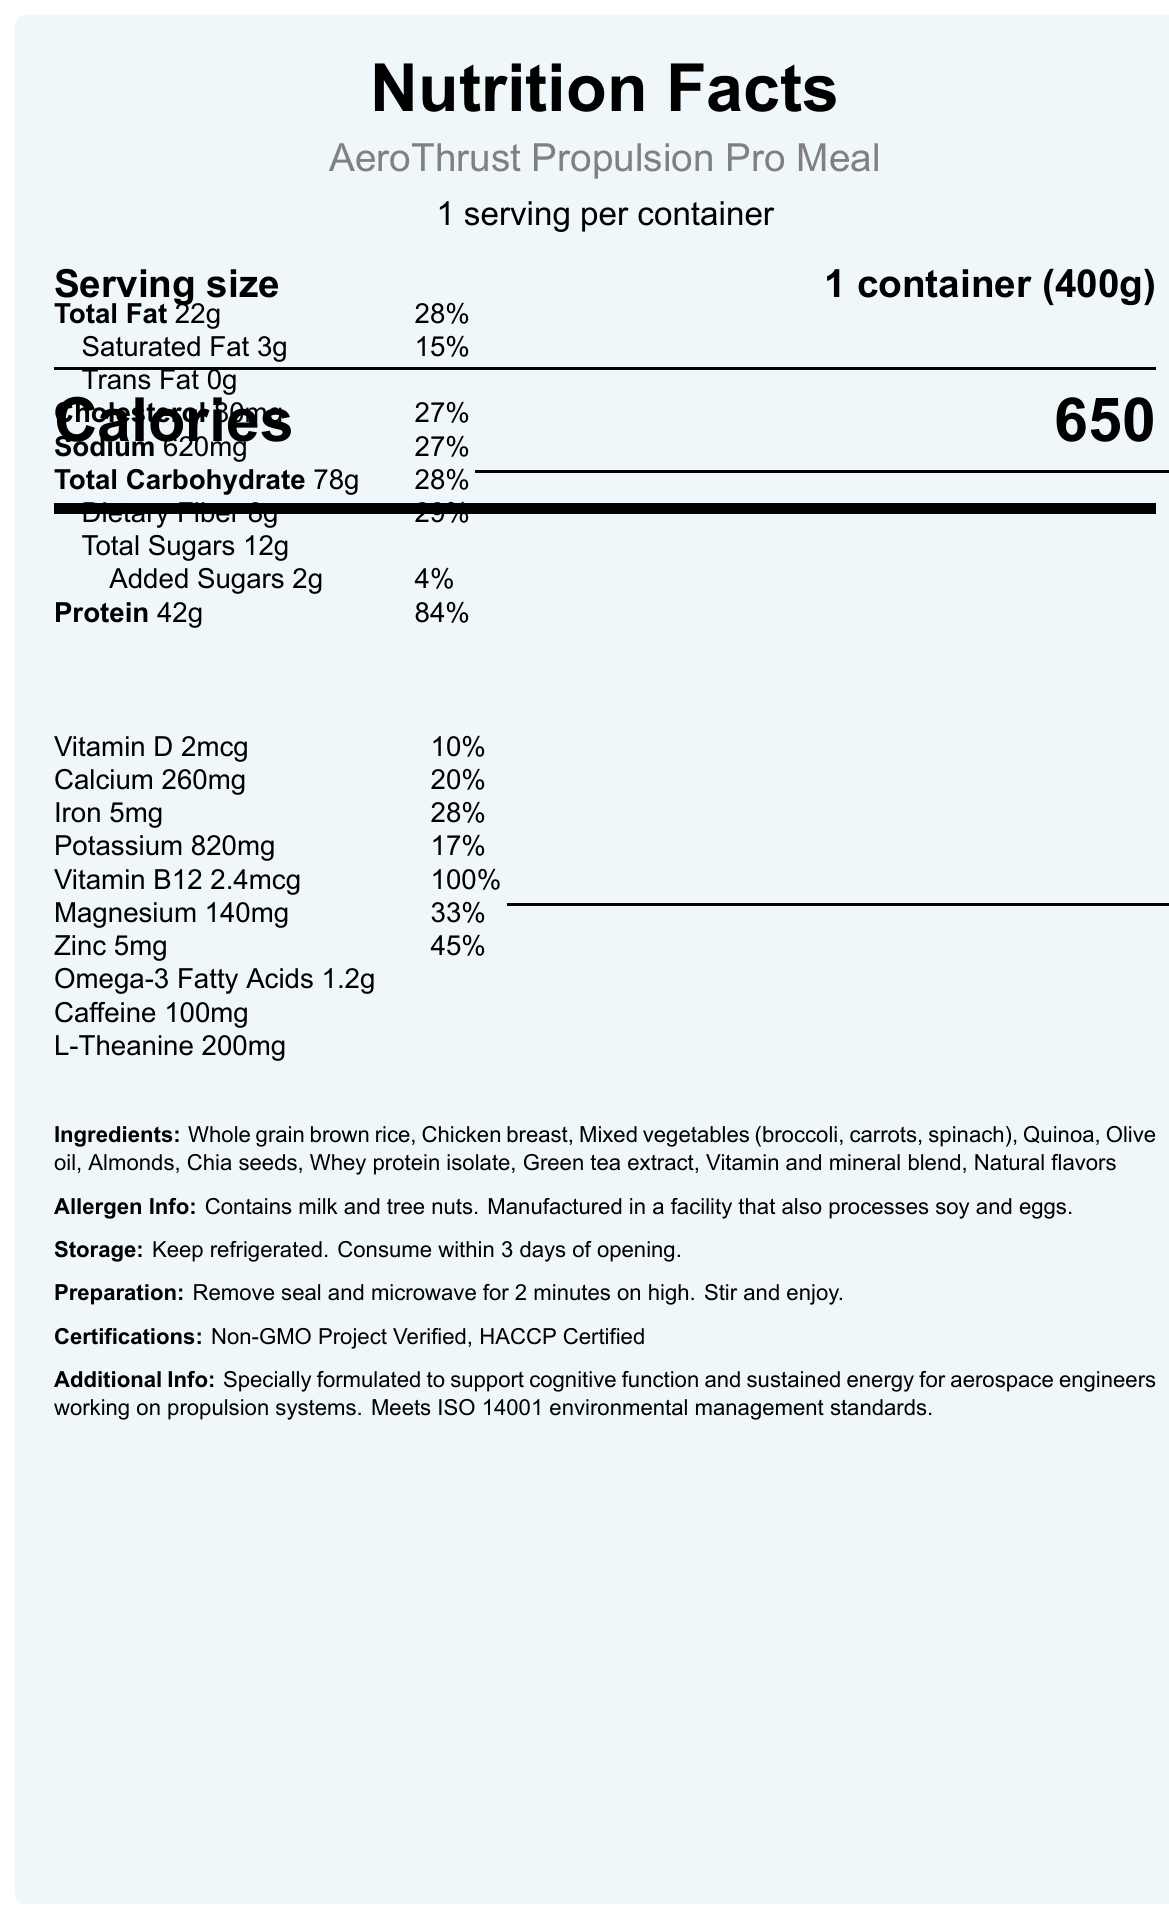What is the serving size of the AeroThrust Propulsion Pro Meal? The serving size is explicitly mentioned as "1 container (400g)" in the document.
Answer: 1 container (400g) How many calories are in one serving? The number of calories per serving is clearly stated as 650 in the document.
Answer: 650 What percentage of the daily value of protein does one serving provide? The document states that the protein content of one serving provides 84% of the daily value.
Answer: 84% List three main ingredients in the AeroThrust Propulsion Pro Meal. These ingredients are the first three items listed under the "Ingredients" section.
Answer: Whole grain brown rice, Chicken breast, Mixed vegetables (broccoli, carrots, spinach) What are the preparation instructions for the meal? The preparation instructions are included at the end of the document and provide detailed steps.
Answer: Remove seal and microwave for 2 minutes on high. Stir and enjoy. Which certification does the AeroThrust Propulsion Pro Meal NOT have? A. Non-GMO Project Verified B. HACCP Certified C. USDA Organic The document lists "Non-GMO Project Verified" and "HACCP Certified," but not "USDA Organic".
Answer: C How much L-Theanine is contained in one serving? A. 100 mg B. 200 mg C. 300 mg D. 400 mg The amount of L-Theanine in one serving is specified as 200 mg in the document.
Answer: B. 200 mg Does the meal contain any trans fat? The document lists the amount of trans fat as "0g," indicating that the meal does not contain any trans fat.
Answer: No What is the main purpose of the AeroThrust Propulsion Pro Meal according to the additional information? The document states the meal is specially formulated to support cognitive function and sustained energy for aerospace engineers working on propulsion systems.
Answer: To support cognitive function and sustained energy for aerospace engineers working on propulsion systems Are there any tree nuts in the product? The allergen information states that the product contains tree nuts.
Answer: Yes Summarize the key nutritional features and purpose of the AeroThrust Propulsion Pro Meal. The document outlines that this meal provides essential nutrients like protein, vitamins, and minerals, tailored to support cognitive function and sustained energy. It also holds certain certifications and is designed for aerospace engineers.
Answer: AeroThrust Propulsion Pro Meal is a nutrient-dense product with 650 calories per 400g container. It includes 42g of protein, various vitamins and minerals, and essential ingredients tailored for cognitive function and sustained energy, especially for aerospace engineers. It is also Non-GMO Project Verified and HACCP Certified. What is the environmental management standard mentioned in the document? The document states that the meal meets ISO 14001 environmental management standards.
Answer: ISO 14001 How much calcium does one serving provide in percentage of daily value? The amount of calcium, given as 260mg, corresponds to 20% of the daily value as stated in the document.
Answer: 20% Does the document mention if soy is present in the ingredients list? The ingredients list does not include soy, but the allergen information mentions that the product is manufactured in a facility that processes soy.
Answer: No, but it is processed in a facility that also processes soy What is the total amount of fat in one serving? The total amount of fat in one serving is listed as 22g in the nutritional information section.
Answer: 22g Explain why the meal might be particularly suited for aerospace engineers. The additional information section notes that the meal is designed to support cognitive function and sustained energy, which are crucial for the demanding work of aerospace engineers.
Answer: Specially formulated to support cognitive function and sustained energy What additional support might the meal provide for work-related performance? The document highlights that the meal is tailored to support cognitive function and sustained energy, which are vital for high-performance work environments.
Answer: Cognitive function and sustained energy How long can the meal be kept refrigerated after opening? The storage instructions specify that the meal should be consumed within 3 days of opening.
Answer: 3 days How many grams of sugar are added to the meal? The nutritional information details that the added sugars amount to 2g per serving.
Answer: 2g What percentage of daily value does the dietary fiber content of the meal represent? The document states that the meal provides 8g of dietary fiber, which is 29% of the daily value.
Answer: 29% Does the document provide information on recommended daily intake values for specific nutrients? The daily values for various nutrients like protein, fat, vitamins, and minerals are specified in the document.
Answer: Yes Is there enough information to understand the exact blend of vitamins and minerals? The document mentions a "Vitamin and mineral blend" but does not provide specific details on the composition of this blend.
Answer: No 